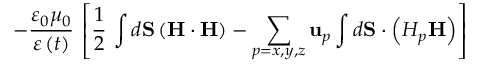<formula> <loc_0><loc_0><loc_500><loc_500>- \frac { \varepsilon _ { 0 } \mu _ { 0 } } { \varepsilon \left ( t \right ) } \, \left [ \frac { 1 } { 2 } \, \int d S \left ( H \cdot H \right ) - \sum _ { p = x , y , z } u _ { p } \int d S \cdot \left ( H _ { p } H \right ) \right ]</formula> 